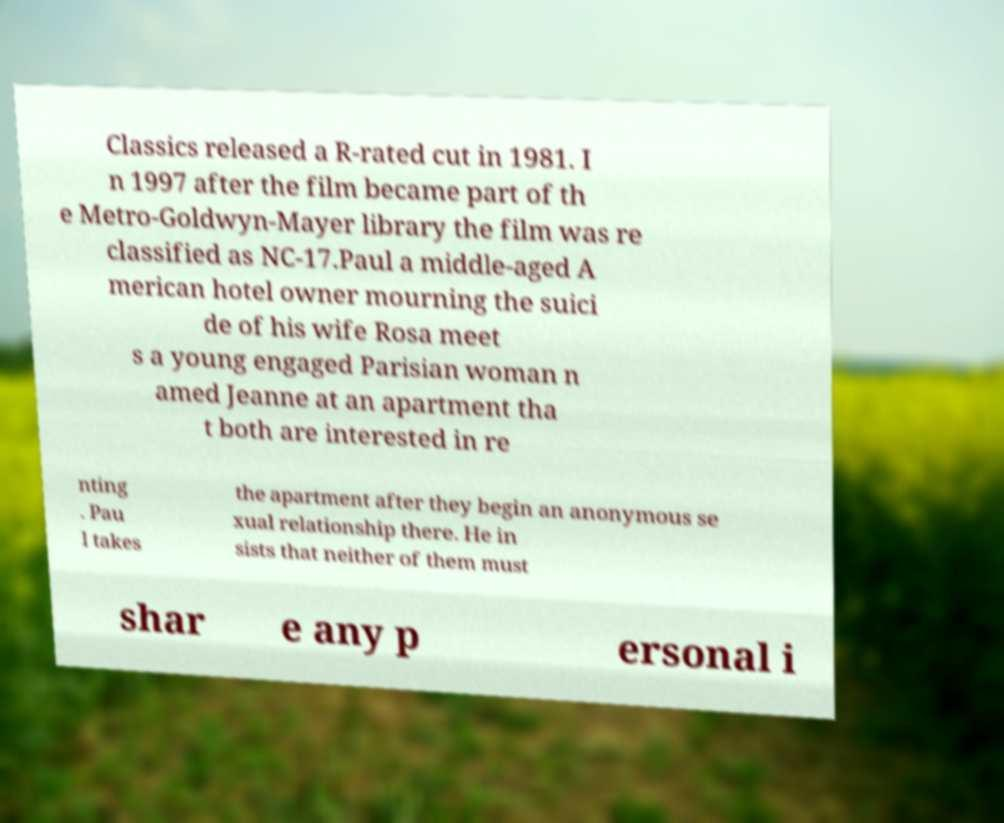Could you assist in decoding the text presented in this image and type it out clearly? Classics released a R-rated cut in 1981. I n 1997 after the film became part of th e Metro-Goldwyn-Mayer library the film was re classified as NC-17.Paul a middle-aged A merican hotel owner mourning the suici de of his wife Rosa meet s a young engaged Parisian woman n amed Jeanne at an apartment tha t both are interested in re nting . Pau l takes the apartment after they begin an anonymous se xual relationship there. He in sists that neither of them must shar e any p ersonal i 